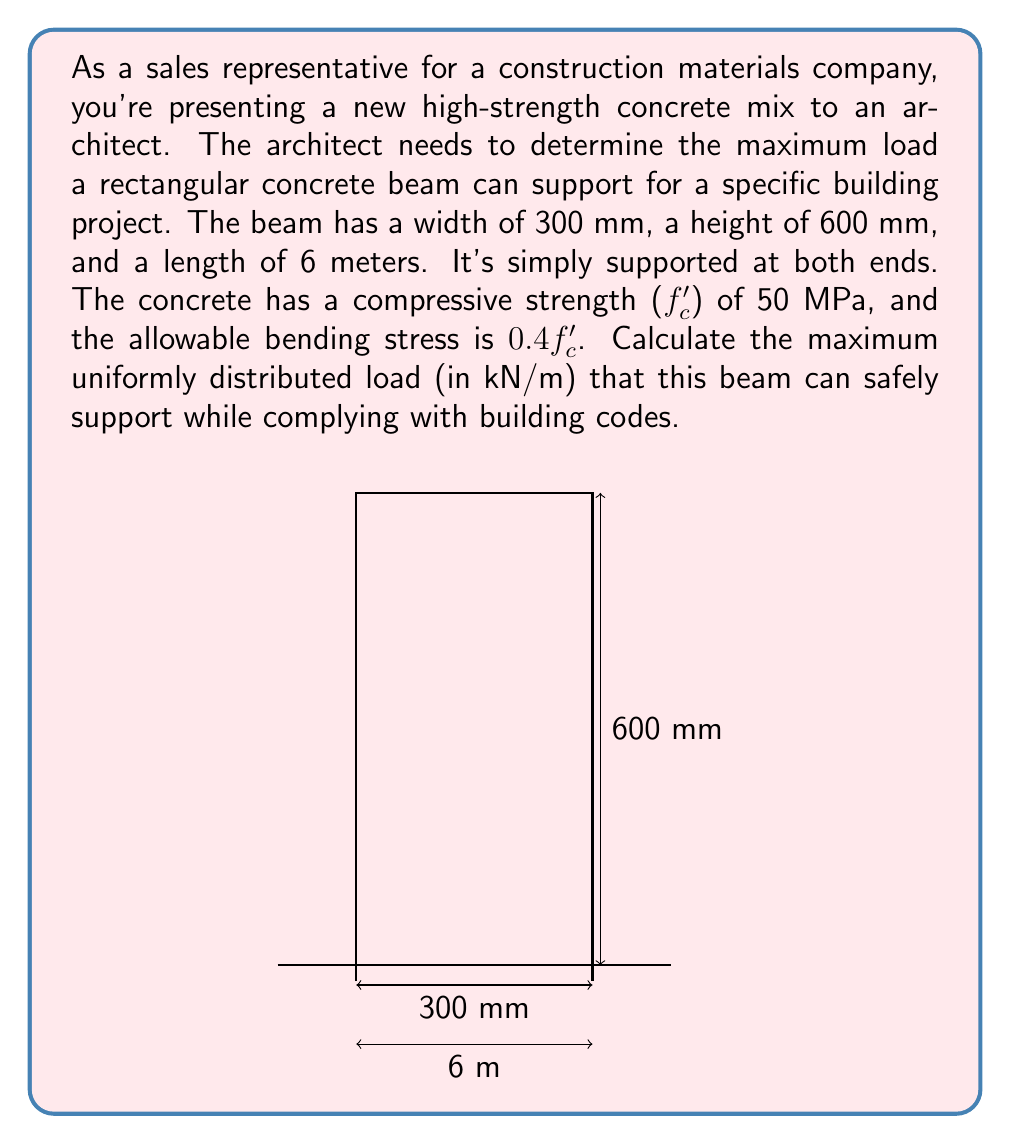Help me with this question. Let's approach this step-by-step:

1) First, we need to calculate the moment of inertia (I) of the beam:
   $$I = \frac{bh^3}{12} = \frac{300 \times 600^3}{12} = 5.4 \times 10^9 \text{ mm}^4$$

2) The section modulus (S) is:
   $$S = \frac{I}{y} = \frac{5.4 \times 10^9}{300} = 18 \times 10^6 \text{ mm}^3$$

3) The allowable bending moment (M) is:
   $$M = S \times \text{allowable stress} = 18 \times 10^6 \times (0.4 \times 50) = 360 \times 10^6 \text{ N·mm}$$

4) For a simply supported beam with uniformly distributed load (w), the maximum bending moment occurs at the center and is given by:
   $$M = \frac{wL^2}{8}$$

   Where L is the length of the beam.

5) Substituting our values:
   $$360 \times 10^6 = \frac{w \times 6000^2}{8}$$

6) Solving for w:
   $$w = \frac{360 \times 10^6 \times 8}{6000^2} = 80 \text{ N/mm} = 80 \text{ kN/m}$$

Therefore, the maximum uniformly distributed load the beam can safely support is 80 kN/m.
Answer: 80 kN/m 